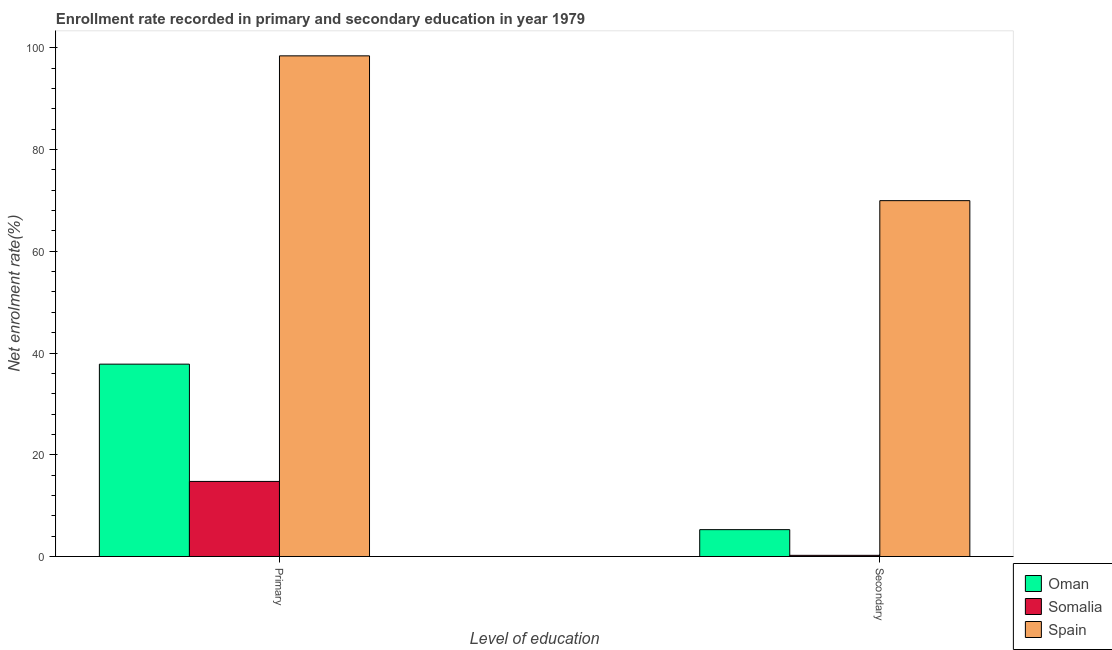How many different coloured bars are there?
Ensure brevity in your answer.  3. Are the number of bars on each tick of the X-axis equal?
Ensure brevity in your answer.  Yes. How many bars are there on the 2nd tick from the left?
Your response must be concise. 3. What is the label of the 2nd group of bars from the left?
Keep it short and to the point. Secondary. What is the enrollment rate in secondary education in Somalia?
Your response must be concise. 0.23. Across all countries, what is the maximum enrollment rate in primary education?
Keep it short and to the point. 98.4. Across all countries, what is the minimum enrollment rate in secondary education?
Give a very brief answer. 0.23. In which country was the enrollment rate in primary education minimum?
Offer a terse response. Somalia. What is the total enrollment rate in primary education in the graph?
Give a very brief answer. 150.97. What is the difference between the enrollment rate in secondary education in Somalia and that in Spain?
Offer a terse response. -69.71. What is the difference between the enrollment rate in secondary education in Oman and the enrollment rate in primary education in Spain?
Make the answer very short. -93.12. What is the average enrollment rate in primary education per country?
Ensure brevity in your answer.  50.32. What is the difference between the enrollment rate in primary education and enrollment rate in secondary education in Spain?
Make the answer very short. 28.46. In how many countries, is the enrollment rate in secondary education greater than 88 %?
Give a very brief answer. 0. What is the ratio of the enrollment rate in secondary education in Oman to that in Spain?
Offer a terse response. 0.08. Is the enrollment rate in secondary education in Spain less than that in Oman?
Give a very brief answer. No. What does the 2nd bar from the left in Secondary represents?
Offer a very short reply. Somalia. Are all the bars in the graph horizontal?
Keep it short and to the point. No. How many countries are there in the graph?
Ensure brevity in your answer.  3. What is the difference between two consecutive major ticks on the Y-axis?
Provide a succinct answer. 20. Does the graph contain any zero values?
Make the answer very short. No. Does the graph contain grids?
Ensure brevity in your answer.  No. How many legend labels are there?
Your answer should be compact. 3. What is the title of the graph?
Make the answer very short. Enrollment rate recorded in primary and secondary education in year 1979. Does "St. Lucia" appear as one of the legend labels in the graph?
Offer a very short reply. No. What is the label or title of the X-axis?
Offer a very short reply. Level of education. What is the label or title of the Y-axis?
Offer a terse response. Net enrolment rate(%). What is the Net enrolment rate(%) in Oman in Primary?
Ensure brevity in your answer.  37.81. What is the Net enrolment rate(%) of Somalia in Primary?
Keep it short and to the point. 14.76. What is the Net enrolment rate(%) of Spain in Primary?
Your answer should be very brief. 98.4. What is the Net enrolment rate(%) in Oman in Secondary?
Keep it short and to the point. 5.28. What is the Net enrolment rate(%) of Somalia in Secondary?
Ensure brevity in your answer.  0.23. What is the Net enrolment rate(%) in Spain in Secondary?
Give a very brief answer. 69.94. Across all Level of education, what is the maximum Net enrolment rate(%) in Oman?
Keep it short and to the point. 37.81. Across all Level of education, what is the maximum Net enrolment rate(%) in Somalia?
Offer a very short reply. 14.76. Across all Level of education, what is the maximum Net enrolment rate(%) in Spain?
Ensure brevity in your answer.  98.4. Across all Level of education, what is the minimum Net enrolment rate(%) in Oman?
Ensure brevity in your answer.  5.28. Across all Level of education, what is the minimum Net enrolment rate(%) of Somalia?
Ensure brevity in your answer.  0.23. Across all Level of education, what is the minimum Net enrolment rate(%) in Spain?
Provide a short and direct response. 69.94. What is the total Net enrolment rate(%) in Oman in the graph?
Your answer should be very brief. 43.09. What is the total Net enrolment rate(%) in Somalia in the graph?
Ensure brevity in your answer.  14.99. What is the total Net enrolment rate(%) in Spain in the graph?
Provide a succinct answer. 168.35. What is the difference between the Net enrolment rate(%) of Oman in Primary and that in Secondary?
Provide a succinct answer. 32.53. What is the difference between the Net enrolment rate(%) in Somalia in Primary and that in Secondary?
Make the answer very short. 14.52. What is the difference between the Net enrolment rate(%) of Spain in Primary and that in Secondary?
Offer a terse response. 28.46. What is the difference between the Net enrolment rate(%) in Oman in Primary and the Net enrolment rate(%) in Somalia in Secondary?
Offer a terse response. 37.57. What is the difference between the Net enrolment rate(%) of Oman in Primary and the Net enrolment rate(%) of Spain in Secondary?
Offer a terse response. -32.14. What is the difference between the Net enrolment rate(%) in Somalia in Primary and the Net enrolment rate(%) in Spain in Secondary?
Give a very brief answer. -55.19. What is the average Net enrolment rate(%) in Oman per Level of education?
Offer a terse response. 21.55. What is the average Net enrolment rate(%) in Somalia per Level of education?
Your response must be concise. 7.5. What is the average Net enrolment rate(%) in Spain per Level of education?
Your answer should be very brief. 84.17. What is the difference between the Net enrolment rate(%) of Oman and Net enrolment rate(%) of Somalia in Primary?
Your answer should be very brief. 23.05. What is the difference between the Net enrolment rate(%) of Oman and Net enrolment rate(%) of Spain in Primary?
Ensure brevity in your answer.  -60.59. What is the difference between the Net enrolment rate(%) of Somalia and Net enrolment rate(%) of Spain in Primary?
Make the answer very short. -83.64. What is the difference between the Net enrolment rate(%) of Oman and Net enrolment rate(%) of Somalia in Secondary?
Make the answer very short. 5.05. What is the difference between the Net enrolment rate(%) in Oman and Net enrolment rate(%) in Spain in Secondary?
Offer a very short reply. -64.66. What is the difference between the Net enrolment rate(%) of Somalia and Net enrolment rate(%) of Spain in Secondary?
Give a very brief answer. -69.71. What is the ratio of the Net enrolment rate(%) in Oman in Primary to that in Secondary?
Your response must be concise. 7.16. What is the ratio of the Net enrolment rate(%) of Somalia in Primary to that in Secondary?
Your answer should be compact. 63.1. What is the ratio of the Net enrolment rate(%) in Spain in Primary to that in Secondary?
Provide a succinct answer. 1.41. What is the difference between the highest and the second highest Net enrolment rate(%) in Oman?
Offer a terse response. 32.53. What is the difference between the highest and the second highest Net enrolment rate(%) in Somalia?
Make the answer very short. 14.52. What is the difference between the highest and the second highest Net enrolment rate(%) of Spain?
Offer a very short reply. 28.46. What is the difference between the highest and the lowest Net enrolment rate(%) in Oman?
Your answer should be compact. 32.53. What is the difference between the highest and the lowest Net enrolment rate(%) in Somalia?
Make the answer very short. 14.52. What is the difference between the highest and the lowest Net enrolment rate(%) of Spain?
Keep it short and to the point. 28.46. 